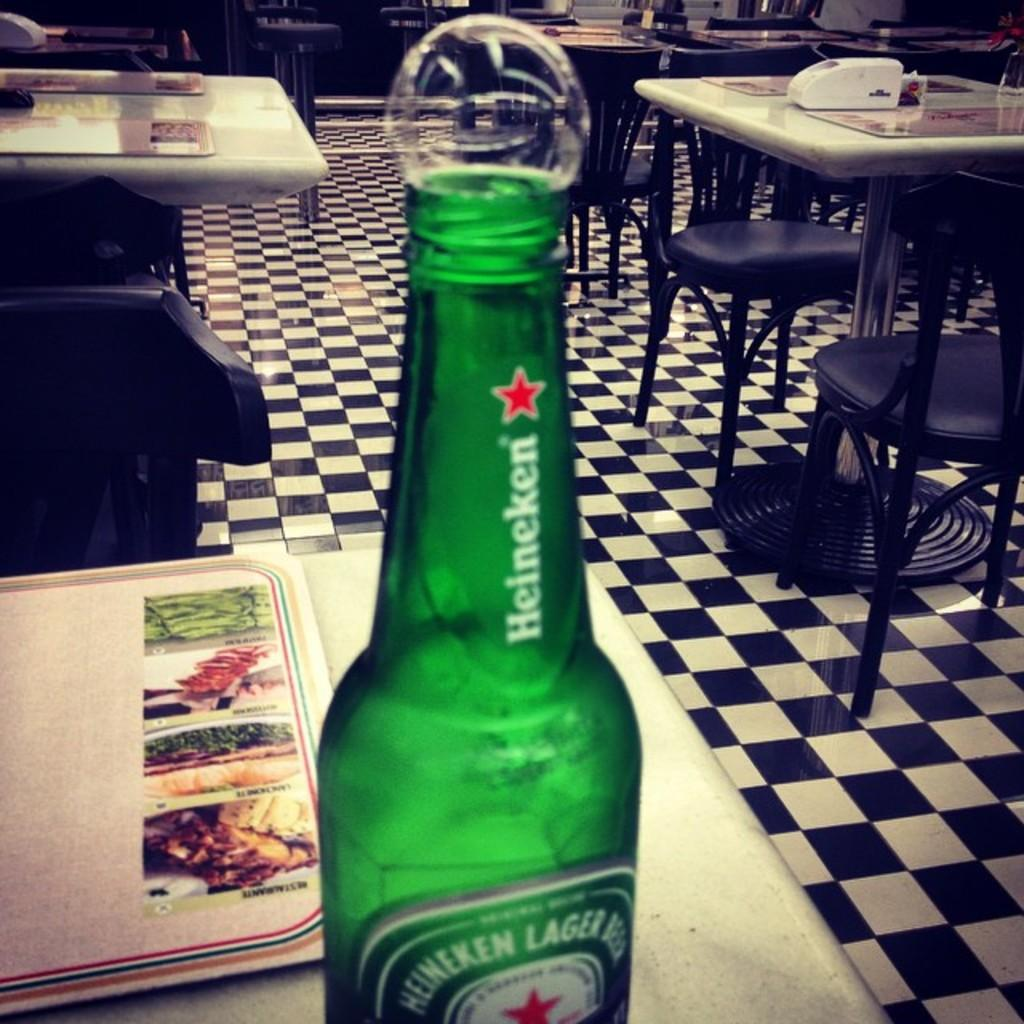What type of furniture is present in the image? There are tables and chairs in the image. What can be found on one of the tables? There is a green bottle on a table. What might be used for ordering food or drinks in the image? There is a menu card on the table. What type of skirt is the beggar wearing in the image? There is no beggar present in the image, and therefore no skirt to describe. What type of mineral can be seen on the table in the image? There is no mineral, such as quartz, present on the table in the image. 